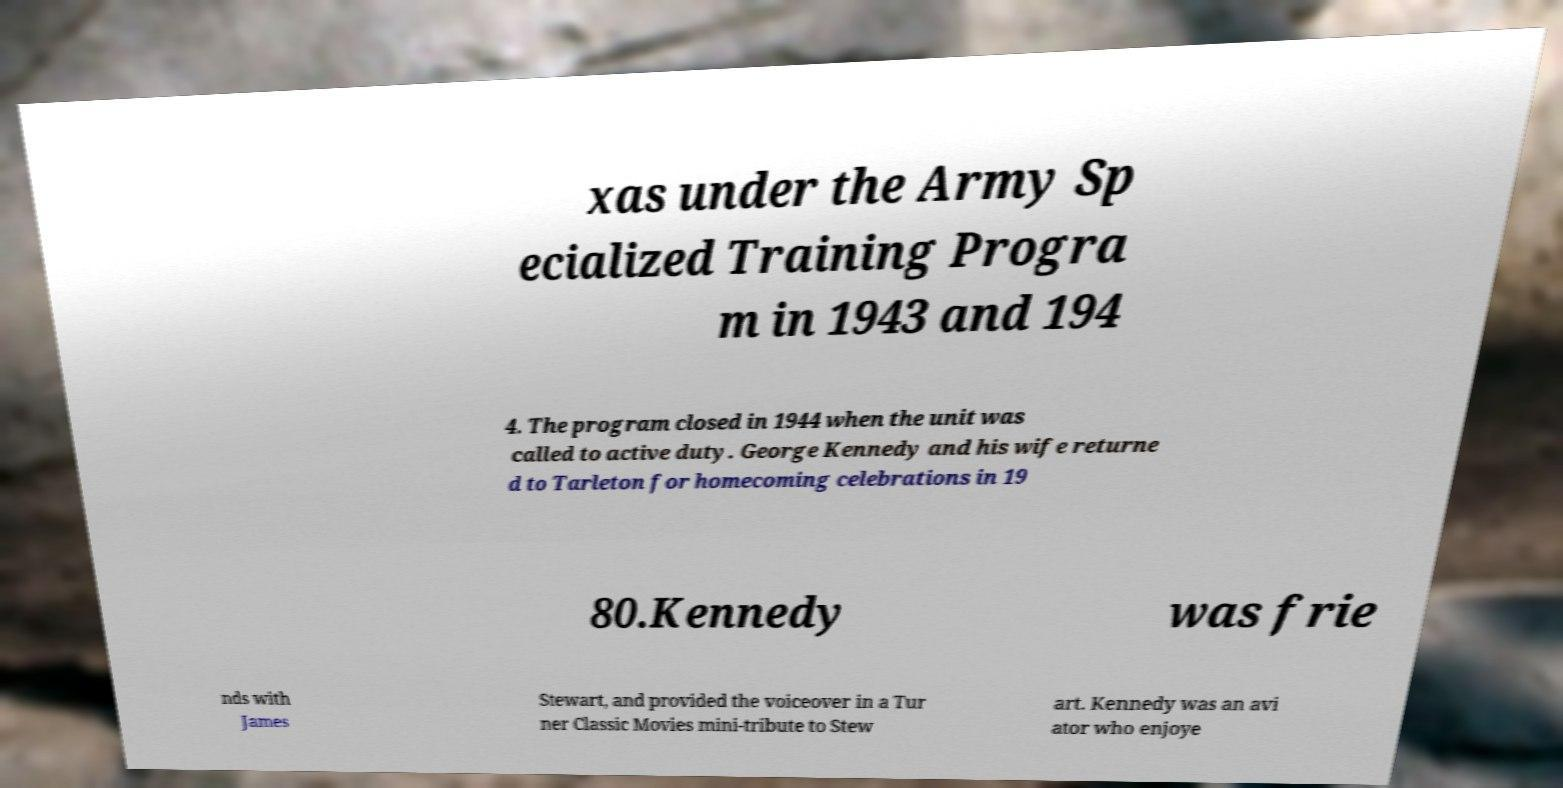Could you assist in decoding the text presented in this image and type it out clearly? xas under the Army Sp ecialized Training Progra m in 1943 and 194 4. The program closed in 1944 when the unit was called to active duty. George Kennedy and his wife returne d to Tarleton for homecoming celebrations in 19 80.Kennedy was frie nds with James Stewart, and provided the voiceover in a Tur ner Classic Movies mini-tribute to Stew art. Kennedy was an avi ator who enjoye 